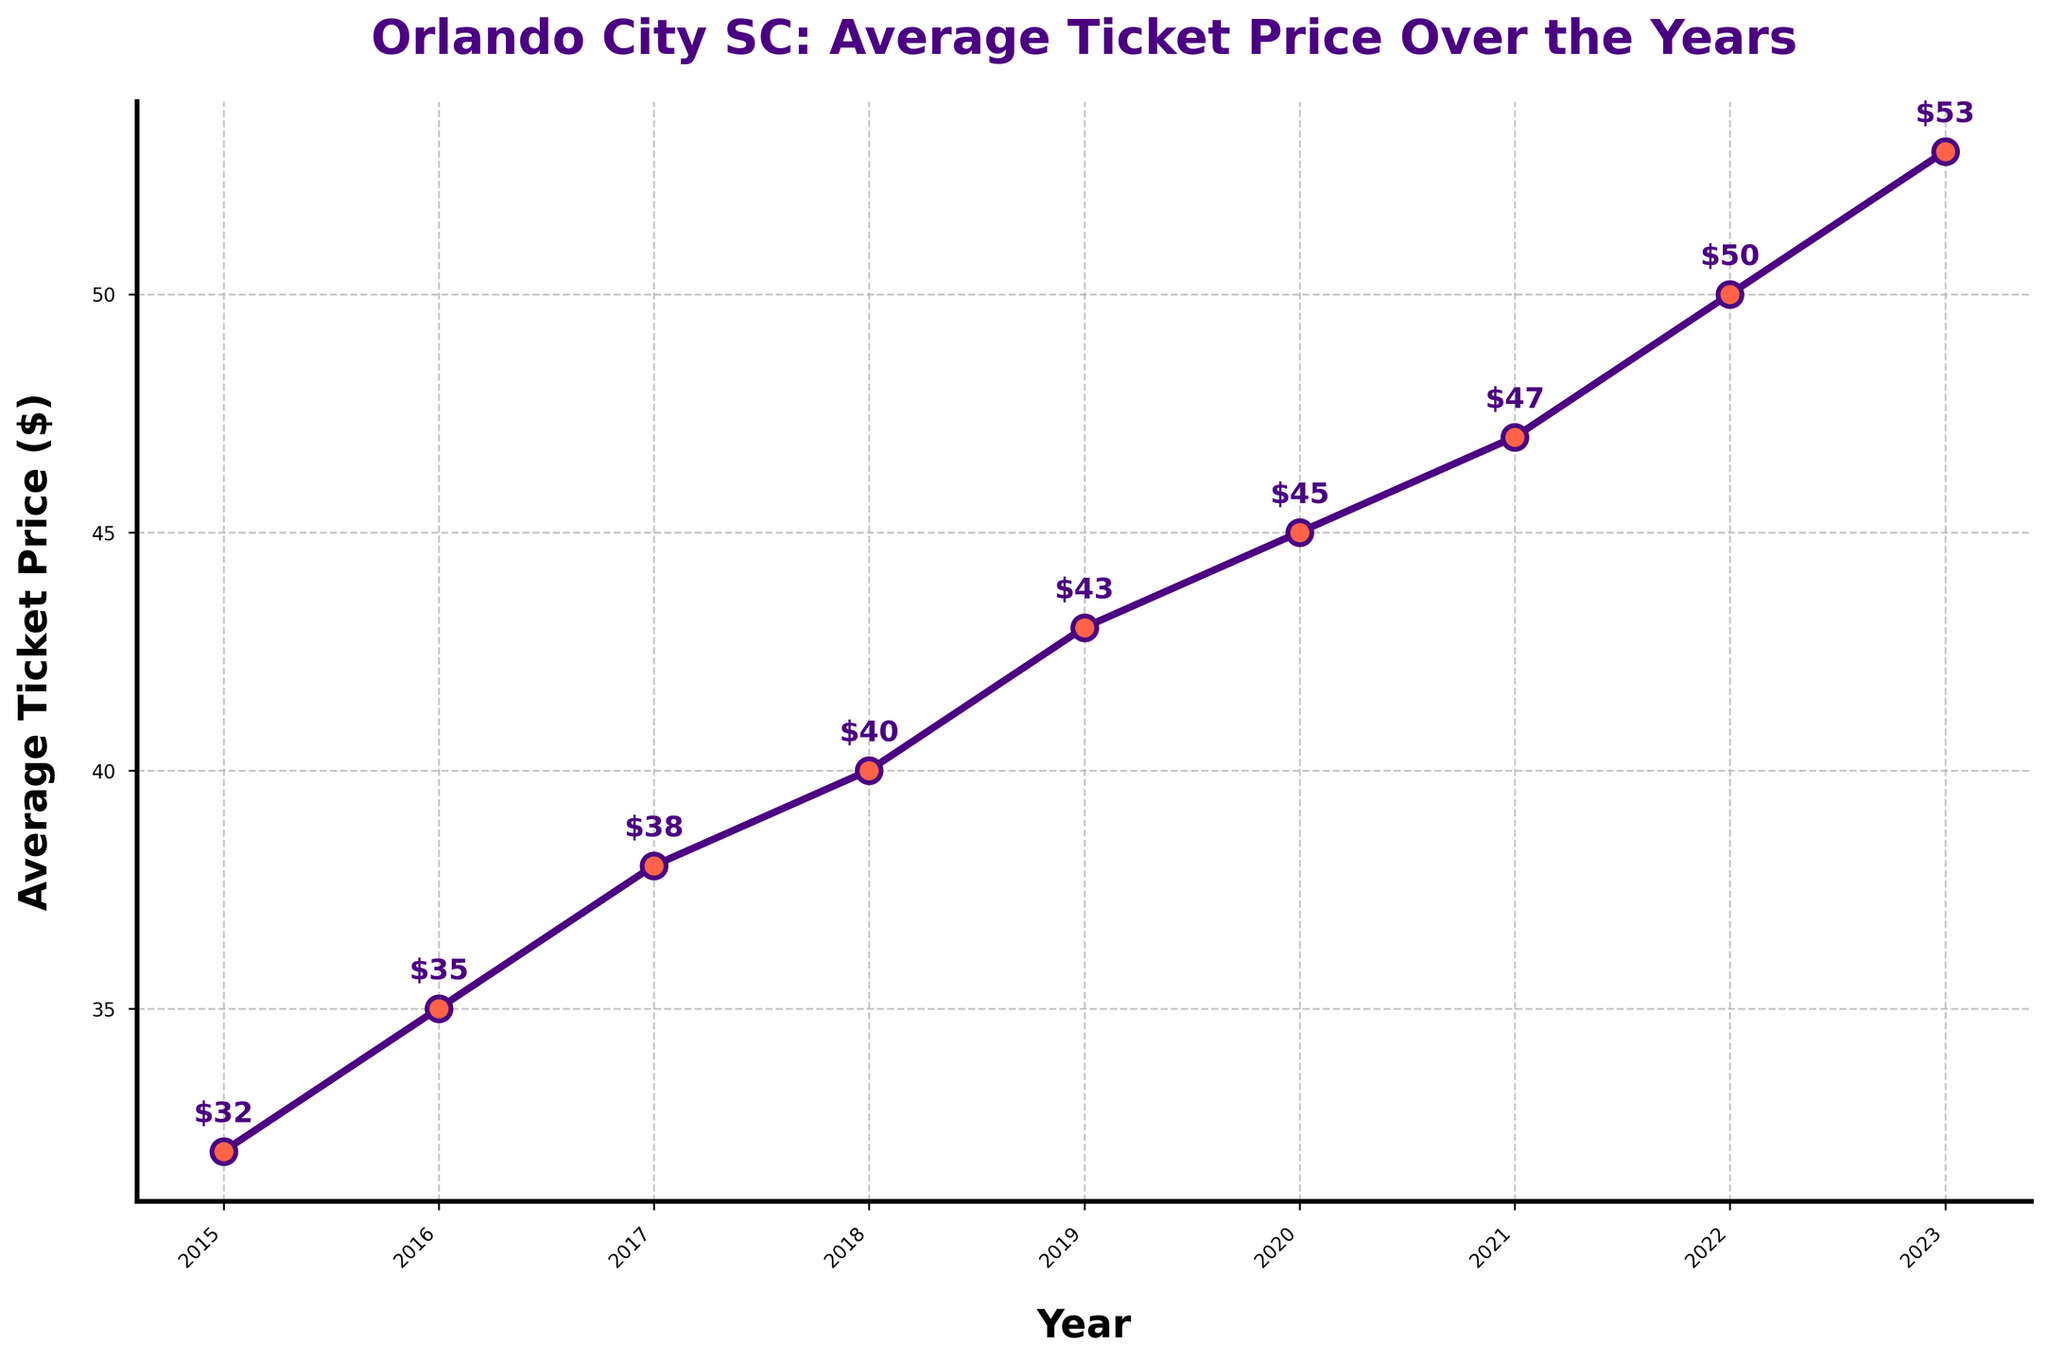What's the average ticket price over the years? To calculate the average ticket price, sum all the prices and divide by the number of years: (32 + 35 + 38 + 40 + 43 + 45 + 47 + 50 + 53) / 9 = 43.67
Answer: 43.67 What is the difference in ticket prices between 2015 and 2023? The ticket price in 2015 is $32 and in 2023 is $53. The difference is 53 - 32 = 21
Answer: 21 Which year had the smallest increase in ticket price compared to the previous year? By comparing the yearly increases: 2015-2016 (3), 2016-2017 (3), 2017-2018 (2), 2018-2019 (3), 2019-2020 (2), 2020-2021 (2), 2021-2022 (3), 2022-2023 (3), the smallest increase is from 2017 to 2018
Answer: 2017 to 2018 How many years did it take for the ticket price to increase from $32 to $45? Find the years corresponding to $32 (2015) and $45 (2020). The difference in years is 2020 - 2015 = 5
Answer: 5 What is the average yearly increase in ticket prices from 2015 to 2023? To find the average yearly increase, divide the total increase by the number of intervals: (53 - 32) / (2023 - 2015) = 21 / 8 = 2.625
Answer: 2.625 Which year had the highest ticket price, and what was it? The year with the highest ticket price is 2023, with a ticket price of $53
Answer: 2023, $53 How does the ticket price in 2020 compare to the ticket price in 2015? The ticket price in 2020 is higher by $13 compared to 2015 (45 - 32 = 13)
Answer: Higher by $13 What is the median ticket price over the years? To find the median, list the prices in order: (32, 35, 38, 40, 43, 45, 47, 50, 53). The middle value is the 5th value, which is $43
Answer: 43 Is there any year where the ticket price remained the same as the previous year? There are no instances in the data where the ticket price remained unchanged from one year to the next
Answer: No By how much did the ticket price increase from 2021 to 2022? The ticket price increased by $3 from 2021 to 2022 (50 - 47 = 3)
Answer: $3 